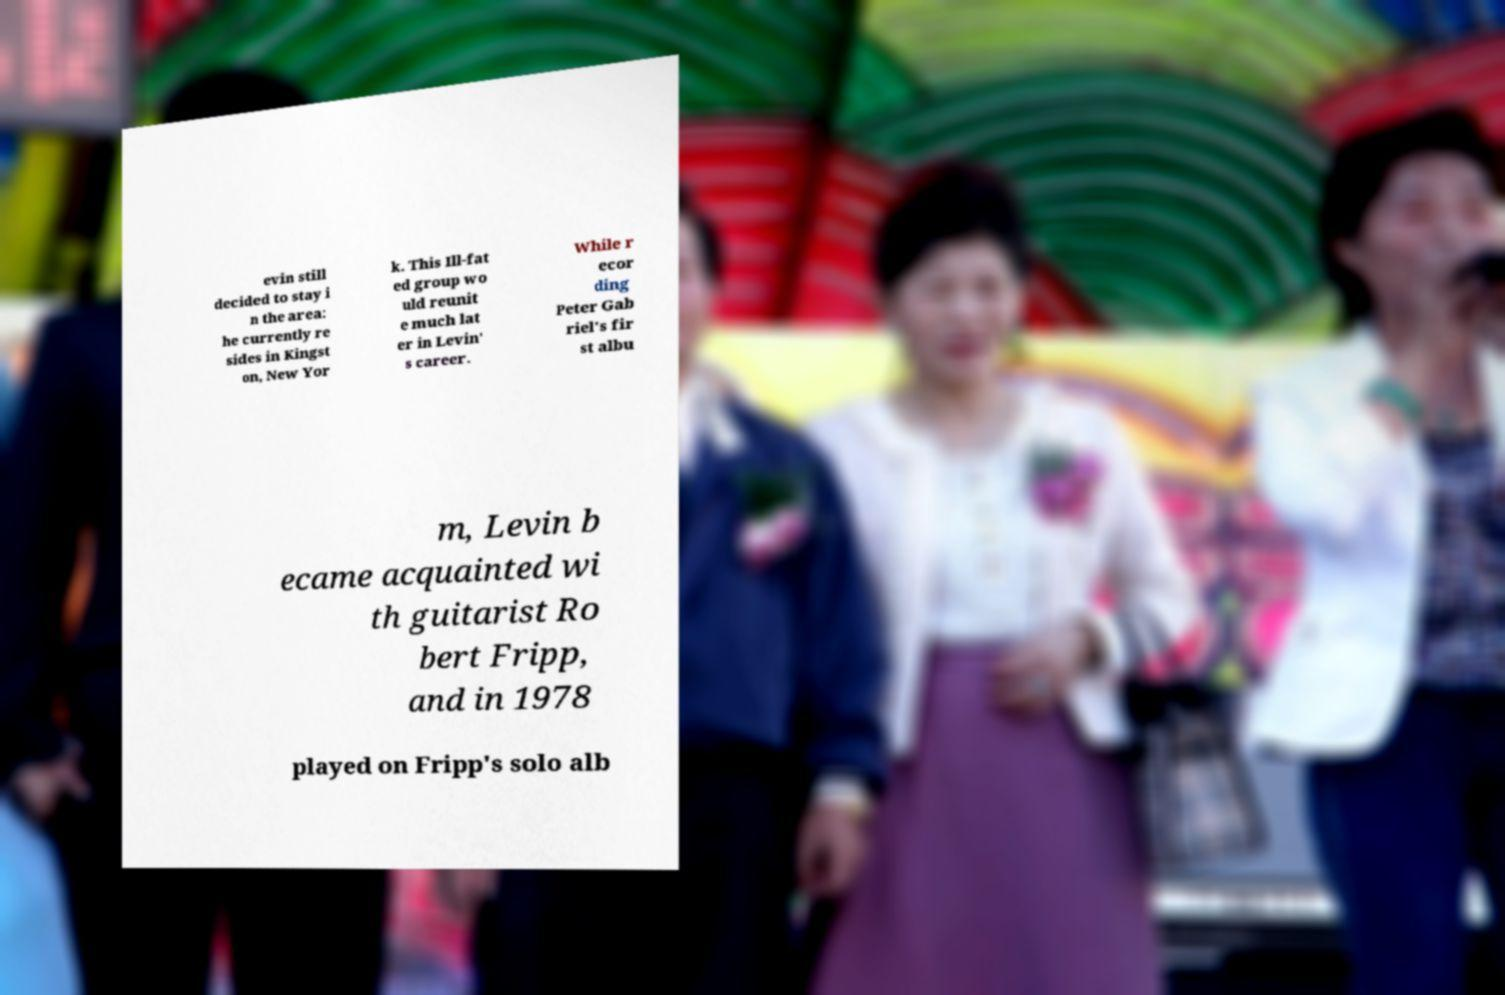Can you read and provide the text displayed in the image?This photo seems to have some interesting text. Can you extract and type it out for me? evin still decided to stay i n the area: he currently re sides in Kingst on, New Yor k. This Ill-fat ed group wo uld reunit e much lat er in Levin' s career. While r ecor ding Peter Gab riel's fir st albu m, Levin b ecame acquainted wi th guitarist Ro bert Fripp, and in 1978 played on Fripp's solo alb 